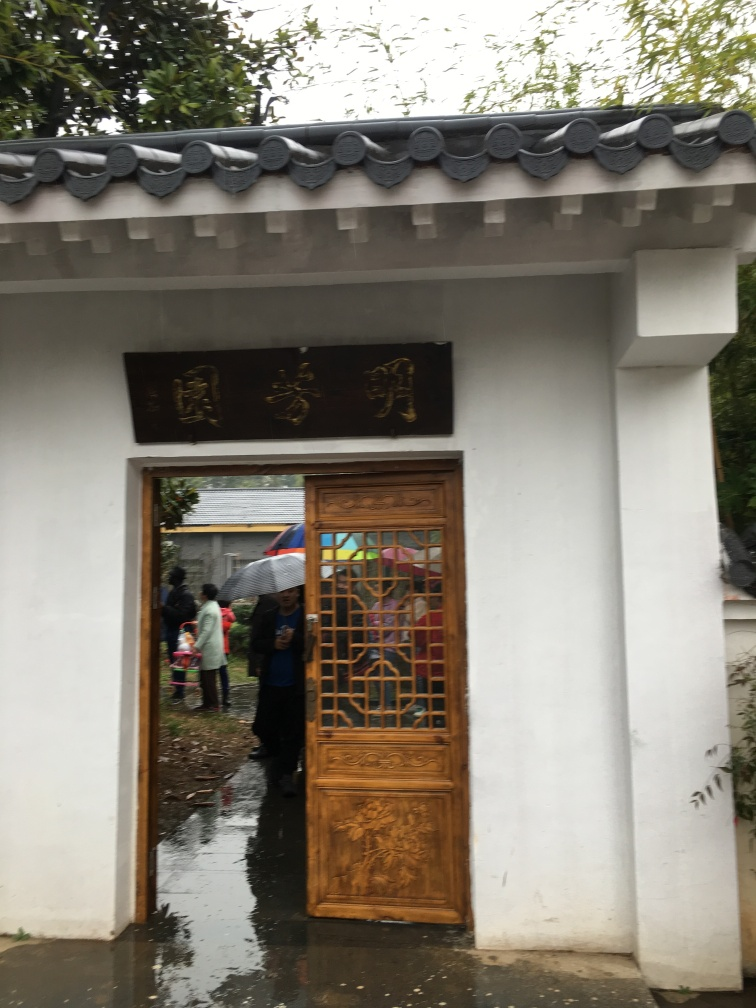Is the image blurry?
 No 